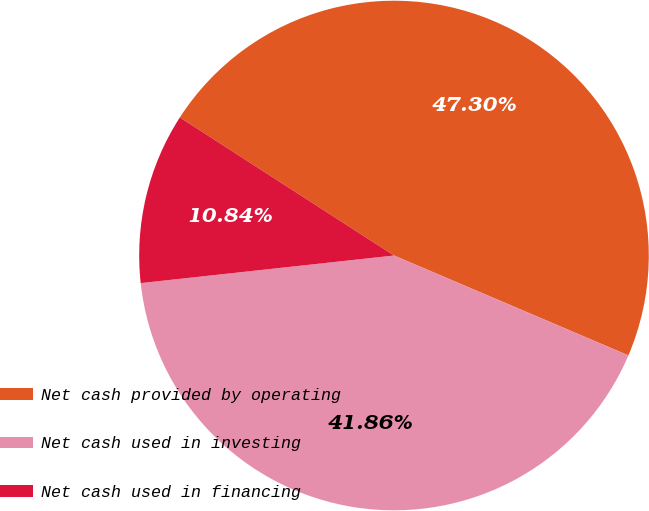Convert chart to OTSL. <chart><loc_0><loc_0><loc_500><loc_500><pie_chart><fcel>Net cash provided by operating<fcel>Net cash used in investing<fcel>Net cash used in financing<nl><fcel>47.3%<fcel>41.86%<fcel>10.84%<nl></chart> 